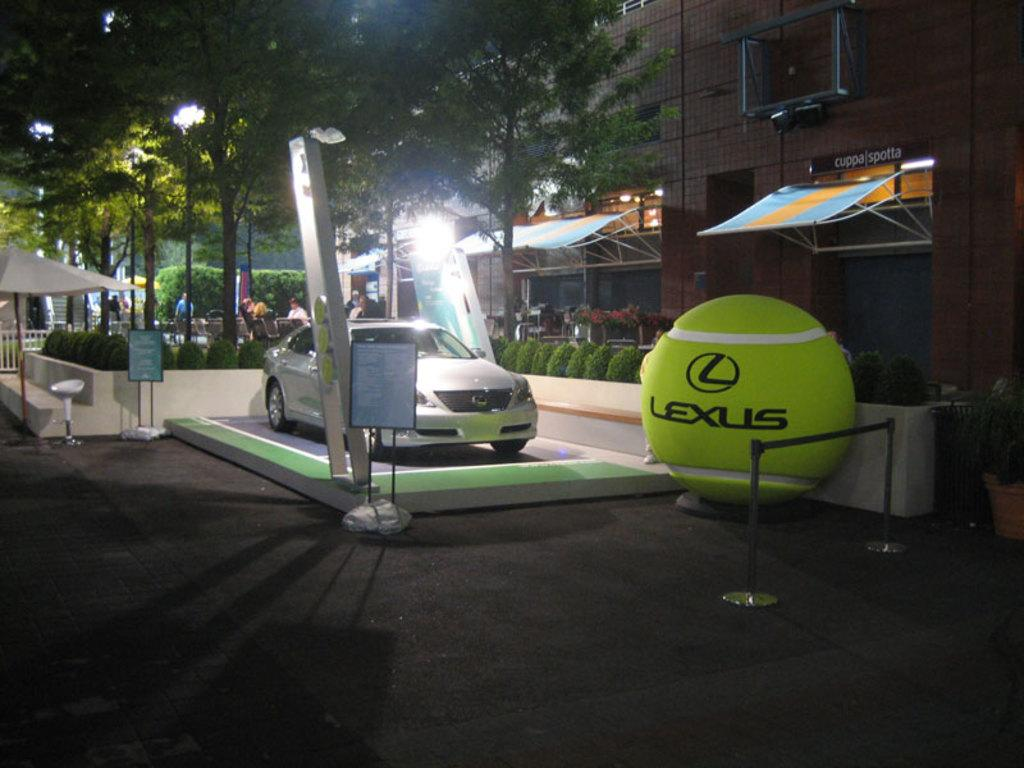What is the main subject of the image? The main subject of the image is a car. What other objects can be seen in the image? There are boards, an umbrella, a ball, house plants, sun shades, and a building in the image. What type of vegetation is present in the image? There are trees in the image. Are there any people visible in the image? Yes, there are people standing in the background of the image. What type of crown is being worn by the ball in the image? There is no crown present in the image, as the main subjects are a car and other objects, not a person or royal figure. 